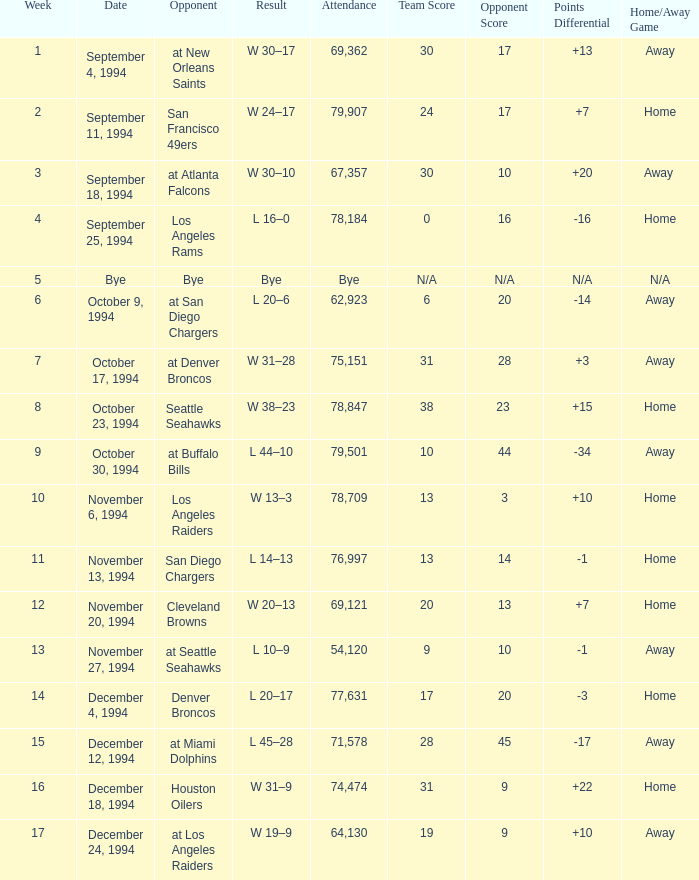Give me the full table as a dictionary. {'header': ['Week', 'Date', 'Opponent', 'Result', 'Attendance', 'Team Score', 'Opponent Score', 'Points Differential', 'Home/Away Game'], 'rows': [['1', 'September 4, 1994', 'at New Orleans Saints', 'W 30–17', '69,362', '30', '17', '+13', 'Away'], ['2', 'September 11, 1994', 'San Francisco 49ers', 'W 24–17', '79,907', '24', '17', '+7', 'Home'], ['3', 'September 18, 1994', 'at Atlanta Falcons', 'W 30–10', '67,357', '30', '10', '+20', 'Away '], ['4', 'September 25, 1994', 'Los Angeles Rams', 'L 16–0', '78,184', '0', '16', '-16', 'Home'], ['5', 'Bye', 'Bye', 'Bye', 'Bye', 'N/A', 'N/A', 'N/A', 'N/A'], ['6', 'October 9, 1994', 'at San Diego Chargers', 'L 20–6', '62,923', '6', '20', '-14', 'Away'], ['7', 'October 17, 1994', 'at Denver Broncos', 'W 31–28', '75,151', '31', '28', '+3', 'Away'], ['8', 'October 23, 1994', 'Seattle Seahawks', 'W 38–23', '78,847', '38', '23 ', '+15', 'Home'], ['9', 'October 30, 1994', 'at Buffalo Bills', 'L 44–10', '79,501', '10', '44', '-34', 'Away'], ['10', 'November 6, 1994', 'Los Angeles Raiders', 'W 13–3', '78,709', '13', '3', '+10', 'Home'], ['11', 'November 13, 1994', 'San Diego Chargers', 'L 14–13', '76,997', '13', '14', '-1', 'Home'], ['12', 'November 20, 1994', 'Cleveland Browns', 'W 20–13', '69,121', '20', '13', '+7', 'Home'], ['13', 'November 27, 1994', 'at Seattle Seahawks', 'L 10–9', '54,120', '9', '10', '-1', 'Away'], ['14', 'December 4, 1994', 'Denver Broncos', 'L 20–17', '77,631', '17', '20', '-3', 'Home'], ['15', 'December 12, 1994', 'at Miami Dolphins', 'L 45–28', '71,578', '28', '45', '-17', 'Away'], ['16', 'December 18, 1994', 'Houston Oilers', 'W 31–9', '74,474', '31', '9', '+22', 'Home'], ['17', 'December 24, 1994', 'at Los Angeles Raiders', 'W 19–9', '64,130', '19', '9', '+10', 'Away']]} What was the score of the Chiefs pre-Week 16 game that 69,362 people attended? W 30–17. 